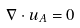Convert formula to latex. <formula><loc_0><loc_0><loc_500><loc_500>\nabla \cdot u _ { A } = 0</formula> 